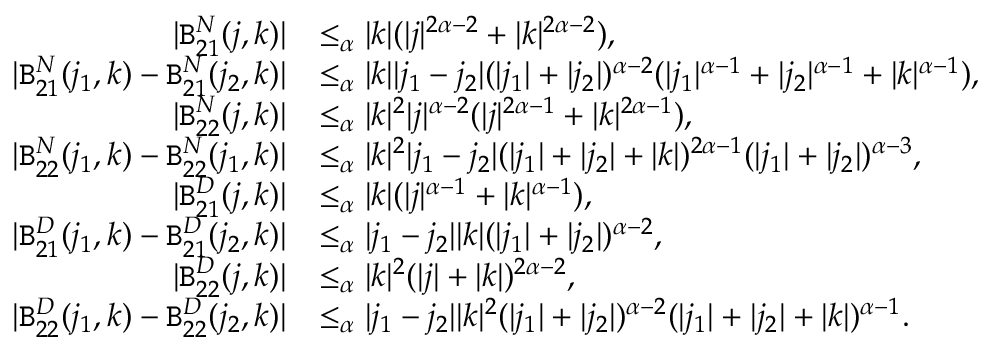Convert formula to latex. <formula><loc_0><loc_0><loc_500><loc_500>\begin{array} { r l } { | B _ { 2 1 } ^ { N } ( j , k ) | } & { \leq _ { \alpha } | k | ( | j | ^ { 2 \alpha - 2 } + | k | ^ { 2 \alpha - 2 } ) , } \\ { | B _ { 2 1 } ^ { N } ( j _ { 1 } , k ) - B _ { 2 1 } ^ { N } ( j _ { 2 } , k ) | } & { \leq _ { \alpha } | k | | j _ { 1 } - j _ { 2 } | ( | j _ { 1 } | + | j _ { 2 } | ) ^ { \alpha - 2 } ( | j _ { 1 } | ^ { \alpha - 1 } + | j _ { 2 } | ^ { \alpha - 1 } + | k | ^ { \alpha - 1 } ) , } \\ { | B _ { 2 2 } ^ { N } ( j , k ) | } & { \leq _ { \alpha } | k | ^ { 2 } | j | ^ { \alpha - 2 } ( | j | ^ { 2 \alpha - 1 } + | k | ^ { 2 \alpha - 1 } ) , } \\ { | B _ { 2 2 } ^ { N } ( j _ { 1 } , k ) - B _ { 2 2 } ^ { N } ( j _ { 1 } , k ) | } & { \leq _ { \alpha } | k | ^ { 2 } | j _ { 1 } - j _ { 2 } | ( | j _ { 1 } | + | j _ { 2 } | + | k | ) ^ { 2 \alpha - 1 } ( | j _ { 1 } | + | j _ { 2 } | ) ^ { \alpha - 3 } , } \\ { | B _ { 2 1 } ^ { D } ( j , k ) | } & { \leq _ { \alpha } | k | ( | j | ^ { \alpha - 1 } + | k | ^ { \alpha - 1 } ) , } \\ { | B _ { 2 1 } ^ { D } ( j _ { 1 } , k ) - B _ { 2 1 } ^ { D } ( j _ { 2 } , k ) | } & { \leq _ { \alpha } | j _ { 1 } - j _ { 2 } | | k | ( | j _ { 1 } | + | j _ { 2 } | ) ^ { \alpha - 2 } , } \\ { | B _ { 2 2 } ^ { D } ( j , k ) | } & { \leq _ { \alpha } | k | ^ { 2 } ( | j | + | k | ) ^ { 2 \alpha - 2 } , } \\ { | B _ { 2 2 } ^ { D } ( j _ { 1 } , k ) - B _ { 2 2 } ^ { D } ( j _ { 2 } , k ) | } & { \leq _ { \alpha } | j _ { 1 } - j _ { 2 } | | k | ^ { 2 } ( | j _ { 1 } | + | j _ { 2 } | ) ^ { \alpha - 2 } ( | j _ { 1 } | + | j _ { 2 } | + | k | ) ^ { \alpha - 1 } . } \end{array}</formula> 